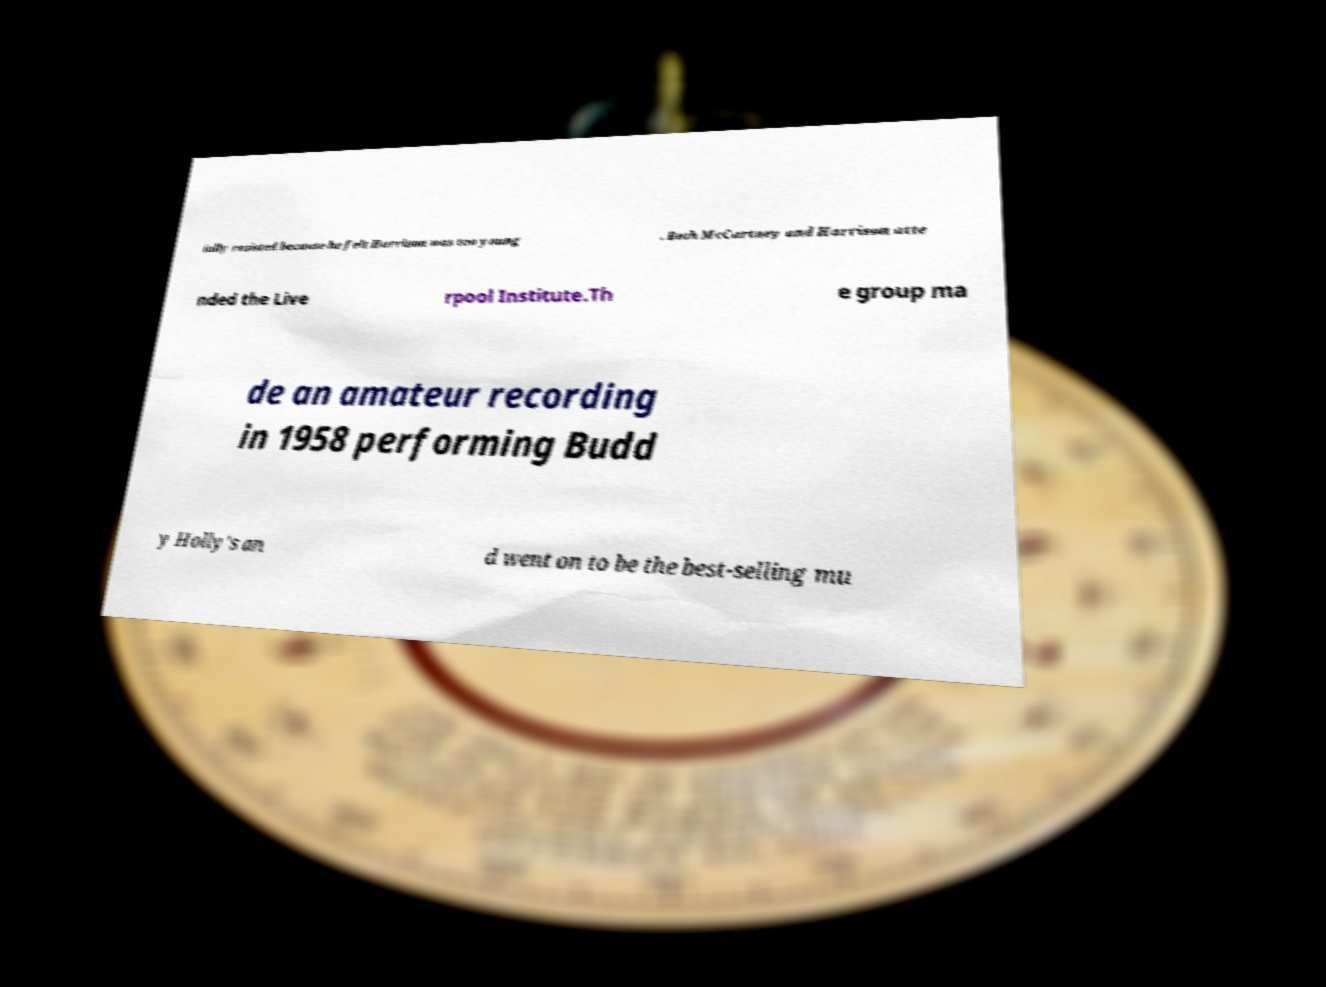I need the written content from this picture converted into text. Can you do that? ially resisted because he felt Harrison was too young . Both McCartney and Harrison atte nded the Live rpool Institute.Th e group ma de an amateur recording in 1958 performing Budd y Holly's an d went on to be the best-selling mu 